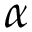<formula> <loc_0><loc_0><loc_500><loc_500>\alpha</formula> 